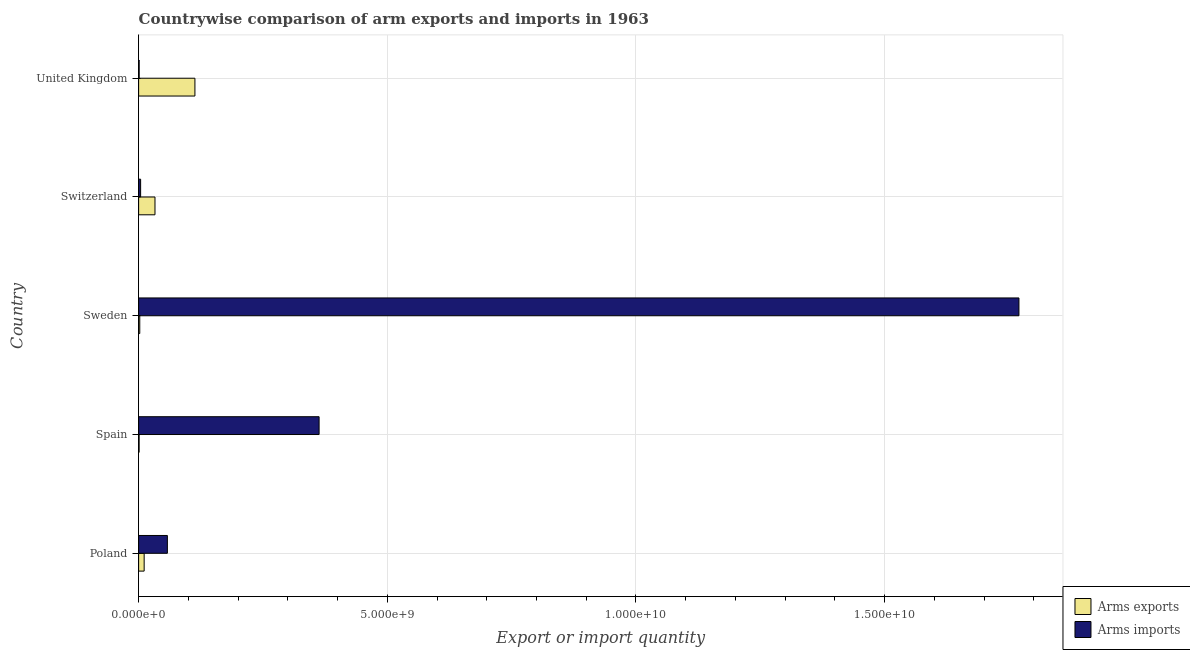How many groups of bars are there?
Make the answer very short. 5. Are the number of bars per tick equal to the number of legend labels?
Your answer should be compact. Yes. Are the number of bars on each tick of the Y-axis equal?
Your answer should be very brief. Yes. How many bars are there on the 2nd tick from the bottom?
Give a very brief answer. 2. What is the label of the 2nd group of bars from the top?
Your answer should be compact. Switzerland. What is the arms imports in United Kingdom?
Ensure brevity in your answer.  1.10e+07. Across all countries, what is the maximum arms exports?
Offer a very short reply. 1.13e+09. Across all countries, what is the minimum arms imports?
Keep it short and to the point. 1.10e+07. In which country was the arms exports minimum?
Your answer should be very brief. Spain. What is the total arms imports in the graph?
Your answer should be compact. 2.20e+1. What is the difference between the arms imports in Poland and that in United Kingdom?
Your response must be concise. 5.67e+08. What is the difference between the arms imports in United Kingdom and the arms exports in Sweden?
Offer a very short reply. -1.20e+07. What is the average arms imports per country?
Provide a succinct answer. 4.39e+09. What is the difference between the arms exports and arms imports in Poland?
Ensure brevity in your answer.  -4.67e+08. What is the ratio of the arms exports in Poland to that in United Kingdom?
Give a very brief answer. 0.1. What is the difference between the highest and the second highest arms imports?
Your answer should be compact. 1.41e+1. What is the difference between the highest and the lowest arms imports?
Your answer should be compact. 1.77e+1. In how many countries, is the arms imports greater than the average arms imports taken over all countries?
Ensure brevity in your answer.  1. What does the 1st bar from the top in Switzerland represents?
Make the answer very short. Arms imports. What does the 1st bar from the bottom in Spain represents?
Your response must be concise. Arms exports. How many bars are there?
Provide a succinct answer. 10. Are all the bars in the graph horizontal?
Your answer should be compact. Yes. How many countries are there in the graph?
Your answer should be very brief. 5. What is the difference between two consecutive major ticks on the X-axis?
Provide a succinct answer. 5.00e+09. Are the values on the major ticks of X-axis written in scientific E-notation?
Your response must be concise. Yes. What is the title of the graph?
Your answer should be compact. Countrywise comparison of arm exports and imports in 1963. Does "Old" appear as one of the legend labels in the graph?
Ensure brevity in your answer.  No. What is the label or title of the X-axis?
Give a very brief answer. Export or import quantity. What is the label or title of the Y-axis?
Give a very brief answer. Country. What is the Export or import quantity of Arms exports in Poland?
Offer a very short reply. 1.11e+08. What is the Export or import quantity of Arms imports in Poland?
Make the answer very short. 5.78e+08. What is the Export or import quantity in Arms imports in Spain?
Provide a succinct answer. 3.63e+09. What is the Export or import quantity of Arms exports in Sweden?
Make the answer very short. 2.30e+07. What is the Export or import quantity in Arms imports in Sweden?
Your answer should be compact. 1.77e+1. What is the Export or import quantity in Arms exports in Switzerland?
Keep it short and to the point. 3.29e+08. What is the Export or import quantity of Arms imports in Switzerland?
Your response must be concise. 4.00e+07. What is the Export or import quantity in Arms exports in United Kingdom?
Your answer should be very brief. 1.13e+09. What is the Export or import quantity of Arms imports in United Kingdom?
Ensure brevity in your answer.  1.10e+07. Across all countries, what is the maximum Export or import quantity of Arms exports?
Offer a terse response. 1.13e+09. Across all countries, what is the maximum Export or import quantity in Arms imports?
Your answer should be compact. 1.77e+1. Across all countries, what is the minimum Export or import quantity in Arms exports?
Give a very brief answer. 1.00e+07. Across all countries, what is the minimum Export or import quantity in Arms imports?
Your response must be concise. 1.10e+07. What is the total Export or import quantity in Arms exports in the graph?
Offer a terse response. 1.60e+09. What is the total Export or import quantity of Arms imports in the graph?
Make the answer very short. 2.20e+1. What is the difference between the Export or import quantity in Arms exports in Poland and that in Spain?
Ensure brevity in your answer.  1.01e+08. What is the difference between the Export or import quantity in Arms imports in Poland and that in Spain?
Give a very brief answer. -3.05e+09. What is the difference between the Export or import quantity of Arms exports in Poland and that in Sweden?
Give a very brief answer. 8.80e+07. What is the difference between the Export or import quantity in Arms imports in Poland and that in Sweden?
Your answer should be very brief. -1.71e+1. What is the difference between the Export or import quantity of Arms exports in Poland and that in Switzerland?
Ensure brevity in your answer.  -2.18e+08. What is the difference between the Export or import quantity in Arms imports in Poland and that in Switzerland?
Offer a terse response. 5.38e+08. What is the difference between the Export or import quantity of Arms exports in Poland and that in United Kingdom?
Give a very brief answer. -1.02e+09. What is the difference between the Export or import quantity of Arms imports in Poland and that in United Kingdom?
Your answer should be compact. 5.67e+08. What is the difference between the Export or import quantity of Arms exports in Spain and that in Sweden?
Your response must be concise. -1.30e+07. What is the difference between the Export or import quantity of Arms imports in Spain and that in Sweden?
Give a very brief answer. -1.41e+1. What is the difference between the Export or import quantity of Arms exports in Spain and that in Switzerland?
Give a very brief answer. -3.19e+08. What is the difference between the Export or import quantity in Arms imports in Spain and that in Switzerland?
Offer a terse response. 3.59e+09. What is the difference between the Export or import quantity of Arms exports in Spain and that in United Kingdom?
Ensure brevity in your answer.  -1.12e+09. What is the difference between the Export or import quantity in Arms imports in Spain and that in United Kingdom?
Your answer should be very brief. 3.62e+09. What is the difference between the Export or import quantity of Arms exports in Sweden and that in Switzerland?
Make the answer very short. -3.06e+08. What is the difference between the Export or import quantity in Arms imports in Sweden and that in Switzerland?
Offer a terse response. 1.77e+1. What is the difference between the Export or import quantity of Arms exports in Sweden and that in United Kingdom?
Your response must be concise. -1.11e+09. What is the difference between the Export or import quantity of Arms imports in Sweden and that in United Kingdom?
Provide a short and direct response. 1.77e+1. What is the difference between the Export or import quantity of Arms exports in Switzerland and that in United Kingdom?
Ensure brevity in your answer.  -8.03e+08. What is the difference between the Export or import quantity in Arms imports in Switzerland and that in United Kingdom?
Keep it short and to the point. 2.90e+07. What is the difference between the Export or import quantity of Arms exports in Poland and the Export or import quantity of Arms imports in Spain?
Offer a very short reply. -3.52e+09. What is the difference between the Export or import quantity of Arms exports in Poland and the Export or import quantity of Arms imports in Sweden?
Make the answer very short. -1.76e+1. What is the difference between the Export or import quantity in Arms exports in Poland and the Export or import quantity in Arms imports in Switzerland?
Provide a short and direct response. 7.10e+07. What is the difference between the Export or import quantity of Arms exports in Spain and the Export or import quantity of Arms imports in Sweden?
Ensure brevity in your answer.  -1.77e+1. What is the difference between the Export or import quantity of Arms exports in Spain and the Export or import quantity of Arms imports in Switzerland?
Your response must be concise. -3.00e+07. What is the difference between the Export or import quantity in Arms exports in Sweden and the Export or import quantity in Arms imports in Switzerland?
Your response must be concise. -1.70e+07. What is the difference between the Export or import quantity of Arms exports in Switzerland and the Export or import quantity of Arms imports in United Kingdom?
Ensure brevity in your answer.  3.18e+08. What is the average Export or import quantity in Arms exports per country?
Your answer should be very brief. 3.21e+08. What is the average Export or import quantity in Arms imports per country?
Give a very brief answer. 4.39e+09. What is the difference between the Export or import quantity in Arms exports and Export or import quantity in Arms imports in Poland?
Offer a terse response. -4.67e+08. What is the difference between the Export or import quantity of Arms exports and Export or import quantity of Arms imports in Spain?
Keep it short and to the point. -3.62e+09. What is the difference between the Export or import quantity of Arms exports and Export or import quantity of Arms imports in Sweden?
Provide a short and direct response. -1.77e+1. What is the difference between the Export or import quantity in Arms exports and Export or import quantity in Arms imports in Switzerland?
Make the answer very short. 2.89e+08. What is the difference between the Export or import quantity of Arms exports and Export or import quantity of Arms imports in United Kingdom?
Keep it short and to the point. 1.12e+09. What is the ratio of the Export or import quantity in Arms imports in Poland to that in Spain?
Offer a terse response. 0.16. What is the ratio of the Export or import quantity of Arms exports in Poland to that in Sweden?
Your answer should be compact. 4.83. What is the ratio of the Export or import quantity in Arms imports in Poland to that in Sweden?
Give a very brief answer. 0.03. What is the ratio of the Export or import quantity of Arms exports in Poland to that in Switzerland?
Provide a succinct answer. 0.34. What is the ratio of the Export or import quantity of Arms imports in Poland to that in Switzerland?
Your answer should be very brief. 14.45. What is the ratio of the Export or import quantity of Arms exports in Poland to that in United Kingdom?
Make the answer very short. 0.1. What is the ratio of the Export or import quantity of Arms imports in Poland to that in United Kingdom?
Your answer should be very brief. 52.55. What is the ratio of the Export or import quantity of Arms exports in Spain to that in Sweden?
Your answer should be very brief. 0.43. What is the ratio of the Export or import quantity in Arms imports in Spain to that in Sweden?
Offer a very short reply. 0.2. What is the ratio of the Export or import quantity of Arms exports in Spain to that in Switzerland?
Your response must be concise. 0.03. What is the ratio of the Export or import quantity of Arms imports in Spain to that in Switzerland?
Your answer should be compact. 90.72. What is the ratio of the Export or import quantity in Arms exports in Spain to that in United Kingdom?
Offer a terse response. 0.01. What is the ratio of the Export or import quantity in Arms imports in Spain to that in United Kingdom?
Provide a succinct answer. 329.91. What is the ratio of the Export or import quantity of Arms exports in Sweden to that in Switzerland?
Your answer should be very brief. 0.07. What is the ratio of the Export or import quantity in Arms imports in Sweden to that in Switzerland?
Your answer should be very brief. 442.55. What is the ratio of the Export or import quantity in Arms exports in Sweden to that in United Kingdom?
Your answer should be compact. 0.02. What is the ratio of the Export or import quantity in Arms imports in Sweden to that in United Kingdom?
Give a very brief answer. 1609.27. What is the ratio of the Export or import quantity of Arms exports in Switzerland to that in United Kingdom?
Make the answer very short. 0.29. What is the ratio of the Export or import quantity of Arms imports in Switzerland to that in United Kingdom?
Give a very brief answer. 3.64. What is the difference between the highest and the second highest Export or import quantity in Arms exports?
Give a very brief answer. 8.03e+08. What is the difference between the highest and the second highest Export or import quantity in Arms imports?
Offer a very short reply. 1.41e+1. What is the difference between the highest and the lowest Export or import quantity in Arms exports?
Provide a short and direct response. 1.12e+09. What is the difference between the highest and the lowest Export or import quantity in Arms imports?
Provide a short and direct response. 1.77e+1. 